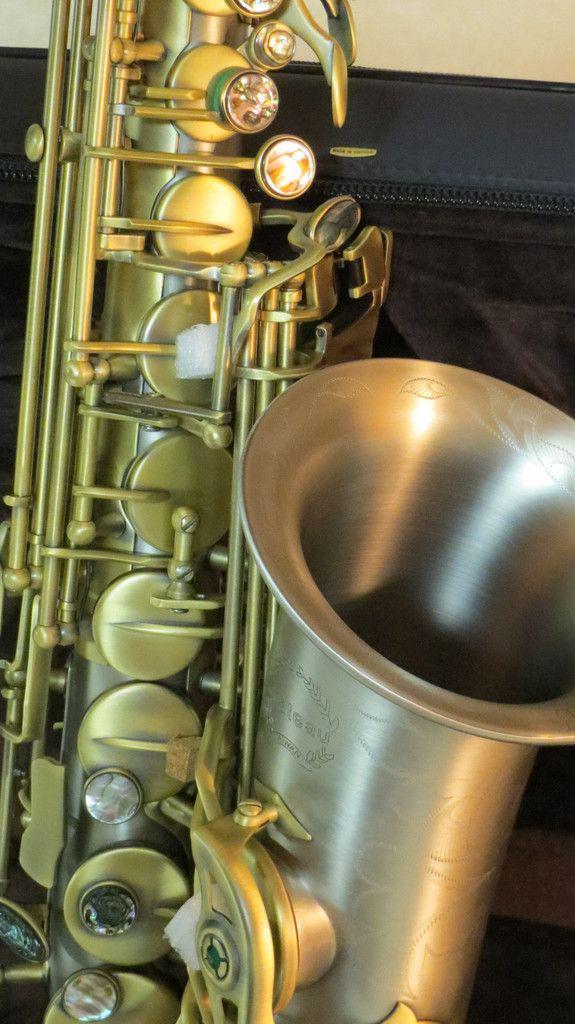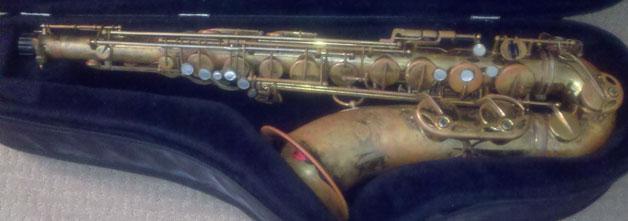The first image is the image on the left, the second image is the image on the right. Considering the images on both sides, is "An image shows a saxophone with a mottled finish, displayed in an open plush-lined case." valid? Answer yes or no. Yes. The first image is the image on the left, the second image is the image on the right. Examine the images to the left and right. Is the description "A saxophone in one image is positioned inside a dark blue lined case, while a second image shows a section of the gold keys of another saxophone." accurate? Answer yes or no. Yes. 